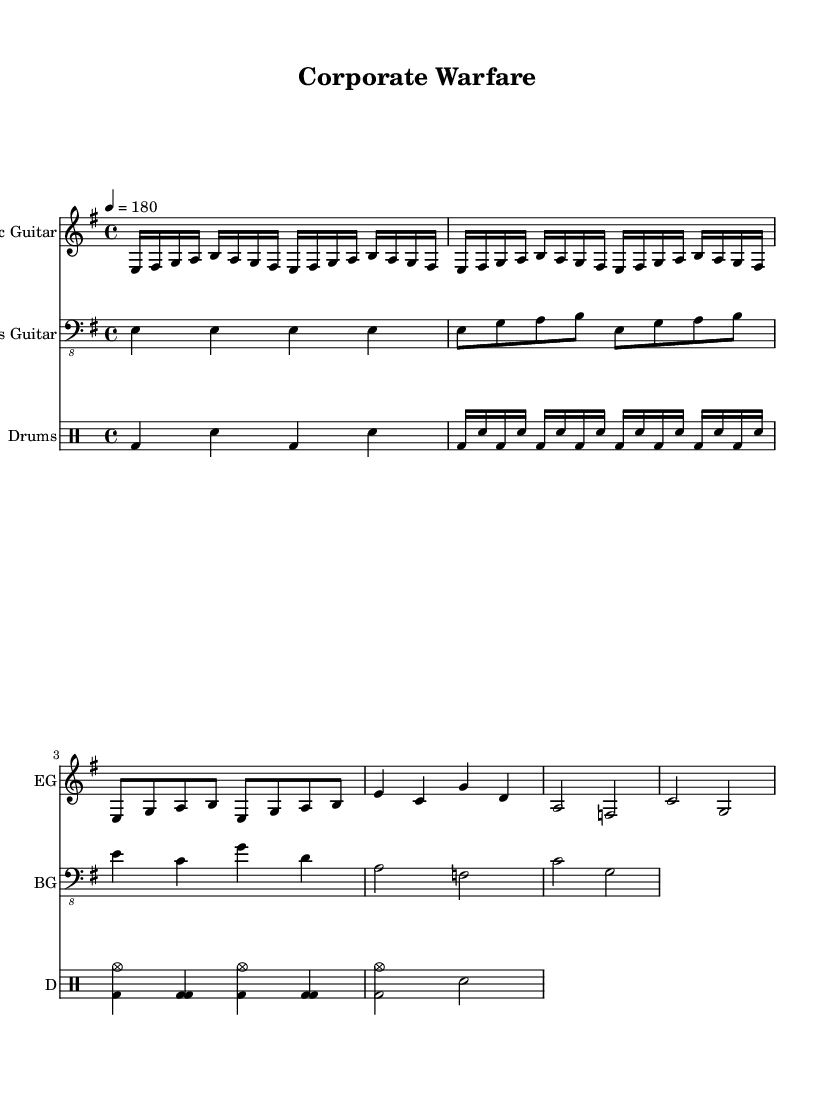What is the key signature of this music? The key signature is indicated by the number of sharps or flats at the beginning of the staff. In this case, there are no sharps or flats shown, which means the key signature is E minor, as the piece is written in that key.
Answer: E minor What is the time signature of this music? The time signature is found at the beginning of the staff as two numbers, one on top of the other. Here, it is indicated as 4/4, meaning there are four beats in a measure and the quarter note gets one beat.
Answer: 4/4 What is the tempo marking of this music? The tempo is indicated by a number followed by the note value, showing how many beats per minute. In this case, it reads "4 = 180", meaning there are 180 beats per minute at the quarter note.
Answer: 180 How many times does the main riff repeat? The main riff section is denoted by the "repeat unfold" directive shown in the music. It specifies that the main riff is played four times in total before moving on to the next section.
Answer: 4 Which section contains a blast beat? By analyzing the drum part, you'll notice that the section after the main riff has a lot of fast snare hits alongside the bass drum, characteristic of a blast beat often played at a fast tempo. This is located in the verse section.
Answer: Verse What type of guitar is used for the main melody? The instrument name is explicitly stated at the beginning of that staff, where it designates the electric guitar as the primary instrument playing the main melody throughout the piece.
Answer: Electric Guitar What is the overall theme of this piece? The title of the piece, "Corporate Warfare," gives an impression of workplace competition and ambition, which is a thematic element frequently explored in aggressive thrash metal music. Analyzing the lyrics or contextual elements would confirm this theme.
Answer: Workplace competition 